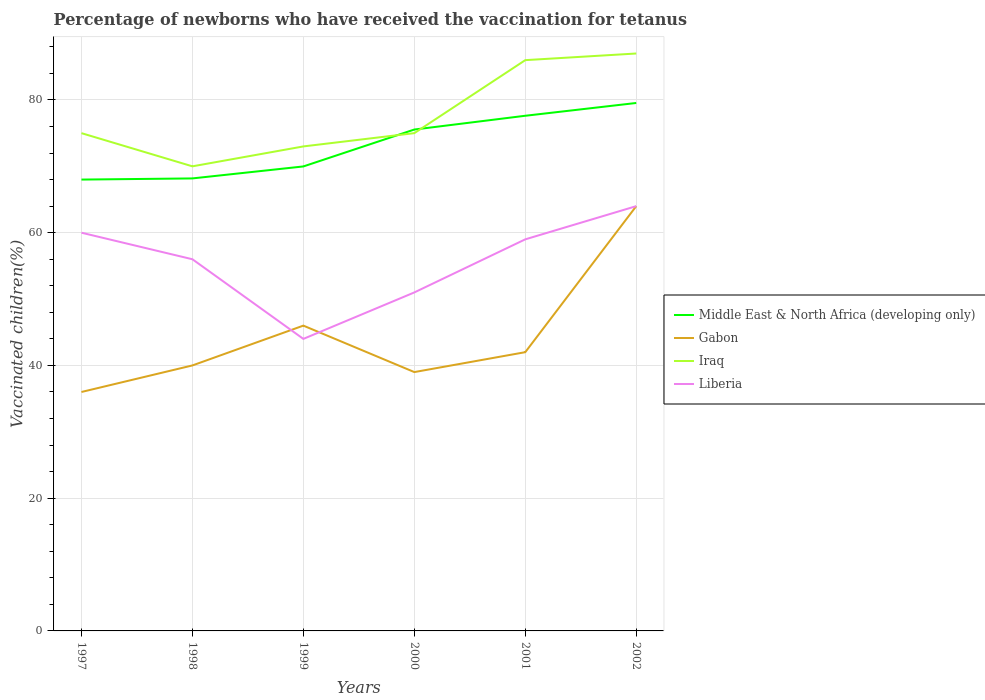Is the number of lines equal to the number of legend labels?
Your answer should be compact. Yes. Across all years, what is the maximum percentage of vaccinated children in Middle East & North Africa (developing only)?
Your response must be concise. 68. What is the total percentage of vaccinated children in Middle East & North Africa (developing only) in the graph?
Provide a succinct answer. -2.07. What is the difference between the highest and the second highest percentage of vaccinated children in Gabon?
Keep it short and to the point. 28. What is the difference between the highest and the lowest percentage of vaccinated children in Liberia?
Give a very brief answer. 4. How many lines are there?
Keep it short and to the point. 4. Does the graph contain grids?
Keep it short and to the point. Yes. Where does the legend appear in the graph?
Provide a short and direct response. Center right. What is the title of the graph?
Your response must be concise. Percentage of newborns who have received the vaccination for tetanus. Does "Brazil" appear as one of the legend labels in the graph?
Offer a very short reply. No. What is the label or title of the Y-axis?
Make the answer very short. Vaccinated children(%). What is the Vaccinated children(%) in Middle East & North Africa (developing only) in 1997?
Your answer should be compact. 68. What is the Vaccinated children(%) of Gabon in 1997?
Offer a very short reply. 36. What is the Vaccinated children(%) of Iraq in 1997?
Your answer should be very brief. 75. What is the Vaccinated children(%) of Middle East & North Africa (developing only) in 1998?
Offer a terse response. 68.18. What is the Vaccinated children(%) in Iraq in 1998?
Your response must be concise. 70. What is the Vaccinated children(%) of Liberia in 1998?
Give a very brief answer. 56. What is the Vaccinated children(%) in Middle East & North Africa (developing only) in 1999?
Ensure brevity in your answer.  69.98. What is the Vaccinated children(%) in Iraq in 1999?
Make the answer very short. 73. What is the Vaccinated children(%) of Middle East & North Africa (developing only) in 2000?
Ensure brevity in your answer.  75.54. What is the Vaccinated children(%) in Gabon in 2000?
Ensure brevity in your answer.  39. What is the Vaccinated children(%) in Iraq in 2000?
Your answer should be very brief. 75. What is the Vaccinated children(%) in Liberia in 2000?
Make the answer very short. 51. What is the Vaccinated children(%) of Middle East & North Africa (developing only) in 2001?
Provide a short and direct response. 77.62. What is the Vaccinated children(%) of Liberia in 2001?
Your response must be concise. 59. What is the Vaccinated children(%) in Middle East & North Africa (developing only) in 2002?
Give a very brief answer. 79.55. What is the Vaccinated children(%) in Gabon in 2002?
Provide a succinct answer. 64. Across all years, what is the maximum Vaccinated children(%) in Middle East & North Africa (developing only)?
Offer a very short reply. 79.55. Across all years, what is the maximum Vaccinated children(%) in Gabon?
Give a very brief answer. 64. Across all years, what is the maximum Vaccinated children(%) of Iraq?
Your response must be concise. 87. Across all years, what is the maximum Vaccinated children(%) of Liberia?
Your answer should be very brief. 64. Across all years, what is the minimum Vaccinated children(%) in Middle East & North Africa (developing only)?
Offer a terse response. 68. Across all years, what is the minimum Vaccinated children(%) in Iraq?
Keep it short and to the point. 70. Across all years, what is the minimum Vaccinated children(%) in Liberia?
Ensure brevity in your answer.  44. What is the total Vaccinated children(%) of Middle East & North Africa (developing only) in the graph?
Ensure brevity in your answer.  438.88. What is the total Vaccinated children(%) in Gabon in the graph?
Provide a succinct answer. 267. What is the total Vaccinated children(%) of Iraq in the graph?
Make the answer very short. 466. What is the total Vaccinated children(%) in Liberia in the graph?
Offer a terse response. 334. What is the difference between the Vaccinated children(%) in Middle East & North Africa (developing only) in 1997 and that in 1998?
Make the answer very short. -0.17. What is the difference between the Vaccinated children(%) in Liberia in 1997 and that in 1998?
Offer a terse response. 4. What is the difference between the Vaccinated children(%) in Middle East & North Africa (developing only) in 1997 and that in 1999?
Your answer should be compact. -1.98. What is the difference between the Vaccinated children(%) in Gabon in 1997 and that in 1999?
Your answer should be very brief. -10. What is the difference between the Vaccinated children(%) in Iraq in 1997 and that in 1999?
Your answer should be very brief. 2. What is the difference between the Vaccinated children(%) of Middle East & North Africa (developing only) in 1997 and that in 2000?
Ensure brevity in your answer.  -7.54. What is the difference between the Vaccinated children(%) in Gabon in 1997 and that in 2000?
Your response must be concise. -3. What is the difference between the Vaccinated children(%) in Liberia in 1997 and that in 2000?
Give a very brief answer. 9. What is the difference between the Vaccinated children(%) of Middle East & North Africa (developing only) in 1997 and that in 2001?
Your answer should be very brief. -9.61. What is the difference between the Vaccinated children(%) of Gabon in 1997 and that in 2001?
Your answer should be very brief. -6. What is the difference between the Vaccinated children(%) of Iraq in 1997 and that in 2001?
Your answer should be compact. -11. What is the difference between the Vaccinated children(%) of Middle East & North Africa (developing only) in 1997 and that in 2002?
Offer a terse response. -11.54. What is the difference between the Vaccinated children(%) of Middle East & North Africa (developing only) in 1998 and that in 1999?
Offer a very short reply. -1.8. What is the difference between the Vaccinated children(%) of Gabon in 1998 and that in 1999?
Your answer should be very brief. -6. What is the difference between the Vaccinated children(%) of Liberia in 1998 and that in 1999?
Provide a succinct answer. 12. What is the difference between the Vaccinated children(%) of Middle East & North Africa (developing only) in 1998 and that in 2000?
Your answer should be compact. -7.37. What is the difference between the Vaccinated children(%) of Gabon in 1998 and that in 2000?
Make the answer very short. 1. What is the difference between the Vaccinated children(%) in Liberia in 1998 and that in 2000?
Keep it short and to the point. 5. What is the difference between the Vaccinated children(%) of Middle East & North Africa (developing only) in 1998 and that in 2001?
Ensure brevity in your answer.  -9.44. What is the difference between the Vaccinated children(%) of Middle East & North Africa (developing only) in 1998 and that in 2002?
Provide a short and direct response. -11.37. What is the difference between the Vaccinated children(%) of Gabon in 1998 and that in 2002?
Ensure brevity in your answer.  -24. What is the difference between the Vaccinated children(%) in Liberia in 1998 and that in 2002?
Offer a terse response. -8. What is the difference between the Vaccinated children(%) of Middle East & North Africa (developing only) in 1999 and that in 2000?
Keep it short and to the point. -5.56. What is the difference between the Vaccinated children(%) of Gabon in 1999 and that in 2000?
Provide a short and direct response. 7. What is the difference between the Vaccinated children(%) in Middle East & North Africa (developing only) in 1999 and that in 2001?
Keep it short and to the point. -7.63. What is the difference between the Vaccinated children(%) in Liberia in 1999 and that in 2001?
Give a very brief answer. -15. What is the difference between the Vaccinated children(%) in Middle East & North Africa (developing only) in 1999 and that in 2002?
Offer a very short reply. -9.56. What is the difference between the Vaccinated children(%) in Gabon in 1999 and that in 2002?
Your answer should be very brief. -18. What is the difference between the Vaccinated children(%) of Liberia in 1999 and that in 2002?
Your answer should be compact. -20. What is the difference between the Vaccinated children(%) in Middle East & North Africa (developing only) in 2000 and that in 2001?
Make the answer very short. -2.07. What is the difference between the Vaccinated children(%) in Gabon in 2000 and that in 2001?
Your answer should be compact. -3. What is the difference between the Vaccinated children(%) in Iraq in 2000 and that in 2001?
Your response must be concise. -11. What is the difference between the Vaccinated children(%) of Middle East & North Africa (developing only) in 2000 and that in 2002?
Your response must be concise. -4. What is the difference between the Vaccinated children(%) of Liberia in 2000 and that in 2002?
Your answer should be compact. -13. What is the difference between the Vaccinated children(%) in Middle East & North Africa (developing only) in 2001 and that in 2002?
Make the answer very short. -1.93. What is the difference between the Vaccinated children(%) of Middle East & North Africa (developing only) in 1997 and the Vaccinated children(%) of Gabon in 1998?
Make the answer very short. 28. What is the difference between the Vaccinated children(%) of Middle East & North Africa (developing only) in 1997 and the Vaccinated children(%) of Iraq in 1998?
Provide a succinct answer. -2. What is the difference between the Vaccinated children(%) in Middle East & North Africa (developing only) in 1997 and the Vaccinated children(%) in Liberia in 1998?
Your response must be concise. 12. What is the difference between the Vaccinated children(%) in Gabon in 1997 and the Vaccinated children(%) in Iraq in 1998?
Offer a very short reply. -34. What is the difference between the Vaccinated children(%) in Gabon in 1997 and the Vaccinated children(%) in Liberia in 1998?
Make the answer very short. -20. What is the difference between the Vaccinated children(%) of Iraq in 1997 and the Vaccinated children(%) of Liberia in 1998?
Make the answer very short. 19. What is the difference between the Vaccinated children(%) in Middle East & North Africa (developing only) in 1997 and the Vaccinated children(%) in Gabon in 1999?
Your response must be concise. 22. What is the difference between the Vaccinated children(%) of Middle East & North Africa (developing only) in 1997 and the Vaccinated children(%) of Iraq in 1999?
Ensure brevity in your answer.  -5. What is the difference between the Vaccinated children(%) of Middle East & North Africa (developing only) in 1997 and the Vaccinated children(%) of Liberia in 1999?
Ensure brevity in your answer.  24. What is the difference between the Vaccinated children(%) of Gabon in 1997 and the Vaccinated children(%) of Iraq in 1999?
Your answer should be very brief. -37. What is the difference between the Vaccinated children(%) in Gabon in 1997 and the Vaccinated children(%) in Liberia in 1999?
Offer a terse response. -8. What is the difference between the Vaccinated children(%) in Middle East & North Africa (developing only) in 1997 and the Vaccinated children(%) in Gabon in 2000?
Give a very brief answer. 29. What is the difference between the Vaccinated children(%) of Middle East & North Africa (developing only) in 1997 and the Vaccinated children(%) of Iraq in 2000?
Offer a terse response. -7. What is the difference between the Vaccinated children(%) in Middle East & North Africa (developing only) in 1997 and the Vaccinated children(%) in Liberia in 2000?
Give a very brief answer. 17. What is the difference between the Vaccinated children(%) of Gabon in 1997 and the Vaccinated children(%) of Iraq in 2000?
Offer a terse response. -39. What is the difference between the Vaccinated children(%) in Gabon in 1997 and the Vaccinated children(%) in Liberia in 2000?
Provide a succinct answer. -15. What is the difference between the Vaccinated children(%) of Iraq in 1997 and the Vaccinated children(%) of Liberia in 2000?
Ensure brevity in your answer.  24. What is the difference between the Vaccinated children(%) in Middle East & North Africa (developing only) in 1997 and the Vaccinated children(%) in Gabon in 2001?
Your answer should be compact. 26. What is the difference between the Vaccinated children(%) of Middle East & North Africa (developing only) in 1997 and the Vaccinated children(%) of Iraq in 2001?
Your response must be concise. -18. What is the difference between the Vaccinated children(%) of Middle East & North Africa (developing only) in 1997 and the Vaccinated children(%) of Liberia in 2001?
Your response must be concise. 9. What is the difference between the Vaccinated children(%) in Gabon in 1997 and the Vaccinated children(%) in Liberia in 2001?
Provide a short and direct response. -23. What is the difference between the Vaccinated children(%) of Middle East & North Africa (developing only) in 1997 and the Vaccinated children(%) of Gabon in 2002?
Provide a succinct answer. 4. What is the difference between the Vaccinated children(%) of Middle East & North Africa (developing only) in 1997 and the Vaccinated children(%) of Iraq in 2002?
Keep it short and to the point. -19. What is the difference between the Vaccinated children(%) in Middle East & North Africa (developing only) in 1997 and the Vaccinated children(%) in Liberia in 2002?
Offer a terse response. 4. What is the difference between the Vaccinated children(%) in Gabon in 1997 and the Vaccinated children(%) in Iraq in 2002?
Provide a short and direct response. -51. What is the difference between the Vaccinated children(%) of Gabon in 1997 and the Vaccinated children(%) of Liberia in 2002?
Provide a short and direct response. -28. What is the difference between the Vaccinated children(%) in Middle East & North Africa (developing only) in 1998 and the Vaccinated children(%) in Gabon in 1999?
Provide a succinct answer. 22.18. What is the difference between the Vaccinated children(%) of Middle East & North Africa (developing only) in 1998 and the Vaccinated children(%) of Iraq in 1999?
Your response must be concise. -4.82. What is the difference between the Vaccinated children(%) of Middle East & North Africa (developing only) in 1998 and the Vaccinated children(%) of Liberia in 1999?
Keep it short and to the point. 24.18. What is the difference between the Vaccinated children(%) of Gabon in 1998 and the Vaccinated children(%) of Iraq in 1999?
Provide a succinct answer. -33. What is the difference between the Vaccinated children(%) of Gabon in 1998 and the Vaccinated children(%) of Liberia in 1999?
Keep it short and to the point. -4. What is the difference between the Vaccinated children(%) in Iraq in 1998 and the Vaccinated children(%) in Liberia in 1999?
Your answer should be very brief. 26. What is the difference between the Vaccinated children(%) of Middle East & North Africa (developing only) in 1998 and the Vaccinated children(%) of Gabon in 2000?
Provide a short and direct response. 29.18. What is the difference between the Vaccinated children(%) in Middle East & North Africa (developing only) in 1998 and the Vaccinated children(%) in Iraq in 2000?
Your answer should be very brief. -6.82. What is the difference between the Vaccinated children(%) of Middle East & North Africa (developing only) in 1998 and the Vaccinated children(%) of Liberia in 2000?
Your answer should be compact. 17.18. What is the difference between the Vaccinated children(%) of Gabon in 1998 and the Vaccinated children(%) of Iraq in 2000?
Give a very brief answer. -35. What is the difference between the Vaccinated children(%) of Gabon in 1998 and the Vaccinated children(%) of Liberia in 2000?
Give a very brief answer. -11. What is the difference between the Vaccinated children(%) of Iraq in 1998 and the Vaccinated children(%) of Liberia in 2000?
Provide a short and direct response. 19. What is the difference between the Vaccinated children(%) in Middle East & North Africa (developing only) in 1998 and the Vaccinated children(%) in Gabon in 2001?
Your response must be concise. 26.18. What is the difference between the Vaccinated children(%) of Middle East & North Africa (developing only) in 1998 and the Vaccinated children(%) of Iraq in 2001?
Make the answer very short. -17.82. What is the difference between the Vaccinated children(%) in Middle East & North Africa (developing only) in 1998 and the Vaccinated children(%) in Liberia in 2001?
Provide a succinct answer. 9.18. What is the difference between the Vaccinated children(%) in Gabon in 1998 and the Vaccinated children(%) in Iraq in 2001?
Make the answer very short. -46. What is the difference between the Vaccinated children(%) in Middle East & North Africa (developing only) in 1998 and the Vaccinated children(%) in Gabon in 2002?
Keep it short and to the point. 4.18. What is the difference between the Vaccinated children(%) of Middle East & North Africa (developing only) in 1998 and the Vaccinated children(%) of Iraq in 2002?
Make the answer very short. -18.82. What is the difference between the Vaccinated children(%) in Middle East & North Africa (developing only) in 1998 and the Vaccinated children(%) in Liberia in 2002?
Keep it short and to the point. 4.18. What is the difference between the Vaccinated children(%) of Gabon in 1998 and the Vaccinated children(%) of Iraq in 2002?
Make the answer very short. -47. What is the difference between the Vaccinated children(%) in Middle East & North Africa (developing only) in 1999 and the Vaccinated children(%) in Gabon in 2000?
Ensure brevity in your answer.  30.98. What is the difference between the Vaccinated children(%) in Middle East & North Africa (developing only) in 1999 and the Vaccinated children(%) in Iraq in 2000?
Keep it short and to the point. -5.02. What is the difference between the Vaccinated children(%) in Middle East & North Africa (developing only) in 1999 and the Vaccinated children(%) in Liberia in 2000?
Give a very brief answer. 18.98. What is the difference between the Vaccinated children(%) in Gabon in 1999 and the Vaccinated children(%) in Iraq in 2000?
Your answer should be very brief. -29. What is the difference between the Vaccinated children(%) in Iraq in 1999 and the Vaccinated children(%) in Liberia in 2000?
Ensure brevity in your answer.  22. What is the difference between the Vaccinated children(%) in Middle East & North Africa (developing only) in 1999 and the Vaccinated children(%) in Gabon in 2001?
Give a very brief answer. 27.98. What is the difference between the Vaccinated children(%) of Middle East & North Africa (developing only) in 1999 and the Vaccinated children(%) of Iraq in 2001?
Provide a succinct answer. -16.02. What is the difference between the Vaccinated children(%) in Middle East & North Africa (developing only) in 1999 and the Vaccinated children(%) in Liberia in 2001?
Keep it short and to the point. 10.98. What is the difference between the Vaccinated children(%) of Gabon in 1999 and the Vaccinated children(%) of Liberia in 2001?
Offer a terse response. -13. What is the difference between the Vaccinated children(%) of Iraq in 1999 and the Vaccinated children(%) of Liberia in 2001?
Make the answer very short. 14. What is the difference between the Vaccinated children(%) in Middle East & North Africa (developing only) in 1999 and the Vaccinated children(%) in Gabon in 2002?
Provide a short and direct response. 5.98. What is the difference between the Vaccinated children(%) in Middle East & North Africa (developing only) in 1999 and the Vaccinated children(%) in Iraq in 2002?
Offer a terse response. -17.02. What is the difference between the Vaccinated children(%) of Middle East & North Africa (developing only) in 1999 and the Vaccinated children(%) of Liberia in 2002?
Your answer should be compact. 5.98. What is the difference between the Vaccinated children(%) in Gabon in 1999 and the Vaccinated children(%) in Iraq in 2002?
Offer a terse response. -41. What is the difference between the Vaccinated children(%) of Gabon in 1999 and the Vaccinated children(%) of Liberia in 2002?
Offer a very short reply. -18. What is the difference between the Vaccinated children(%) in Middle East & North Africa (developing only) in 2000 and the Vaccinated children(%) in Gabon in 2001?
Your answer should be very brief. 33.54. What is the difference between the Vaccinated children(%) of Middle East & North Africa (developing only) in 2000 and the Vaccinated children(%) of Iraq in 2001?
Provide a succinct answer. -10.46. What is the difference between the Vaccinated children(%) in Middle East & North Africa (developing only) in 2000 and the Vaccinated children(%) in Liberia in 2001?
Your answer should be compact. 16.54. What is the difference between the Vaccinated children(%) of Gabon in 2000 and the Vaccinated children(%) of Iraq in 2001?
Make the answer very short. -47. What is the difference between the Vaccinated children(%) of Gabon in 2000 and the Vaccinated children(%) of Liberia in 2001?
Ensure brevity in your answer.  -20. What is the difference between the Vaccinated children(%) in Iraq in 2000 and the Vaccinated children(%) in Liberia in 2001?
Offer a terse response. 16. What is the difference between the Vaccinated children(%) in Middle East & North Africa (developing only) in 2000 and the Vaccinated children(%) in Gabon in 2002?
Your response must be concise. 11.54. What is the difference between the Vaccinated children(%) of Middle East & North Africa (developing only) in 2000 and the Vaccinated children(%) of Iraq in 2002?
Make the answer very short. -11.46. What is the difference between the Vaccinated children(%) of Middle East & North Africa (developing only) in 2000 and the Vaccinated children(%) of Liberia in 2002?
Your answer should be very brief. 11.54. What is the difference between the Vaccinated children(%) in Gabon in 2000 and the Vaccinated children(%) in Iraq in 2002?
Your answer should be very brief. -48. What is the difference between the Vaccinated children(%) in Gabon in 2000 and the Vaccinated children(%) in Liberia in 2002?
Provide a succinct answer. -25. What is the difference between the Vaccinated children(%) of Middle East & North Africa (developing only) in 2001 and the Vaccinated children(%) of Gabon in 2002?
Offer a very short reply. 13.62. What is the difference between the Vaccinated children(%) in Middle East & North Africa (developing only) in 2001 and the Vaccinated children(%) in Iraq in 2002?
Offer a terse response. -9.38. What is the difference between the Vaccinated children(%) in Middle East & North Africa (developing only) in 2001 and the Vaccinated children(%) in Liberia in 2002?
Offer a terse response. 13.62. What is the difference between the Vaccinated children(%) of Gabon in 2001 and the Vaccinated children(%) of Iraq in 2002?
Your answer should be very brief. -45. What is the difference between the Vaccinated children(%) of Iraq in 2001 and the Vaccinated children(%) of Liberia in 2002?
Provide a short and direct response. 22. What is the average Vaccinated children(%) of Middle East & North Africa (developing only) per year?
Ensure brevity in your answer.  73.15. What is the average Vaccinated children(%) of Gabon per year?
Provide a short and direct response. 44.5. What is the average Vaccinated children(%) in Iraq per year?
Your answer should be very brief. 77.67. What is the average Vaccinated children(%) of Liberia per year?
Your response must be concise. 55.67. In the year 1997, what is the difference between the Vaccinated children(%) of Middle East & North Africa (developing only) and Vaccinated children(%) of Gabon?
Your answer should be very brief. 32. In the year 1997, what is the difference between the Vaccinated children(%) of Middle East & North Africa (developing only) and Vaccinated children(%) of Iraq?
Your answer should be compact. -7. In the year 1997, what is the difference between the Vaccinated children(%) in Middle East & North Africa (developing only) and Vaccinated children(%) in Liberia?
Offer a very short reply. 8. In the year 1997, what is the difference between the Vaccinated children(%) in Gabon and Vaccinated children(%) in Iraq?
Ensure brevity in your answer.  -39. In the year 1997, what is the difference between the Vaccinated children(%) of Iraq and Vaccinated children(%) of Liberia?
Keep it short and to the point. 15. In the year 1998, what is the difference between the Vaccinated children(%) of Middle East & North Africa (developing only) and Vaccinated children(%) of Gabon?
Give a very brief answer. 28.18. In the year 1998, what is the difference between the Vaccinated children(%) in Middle East & North Africa (developing only) and Vaccinated children(%) in Iraq?
Ensure brevity in your answer.  -1.82. In the year 1998, what is the difference between the Vaccinated children(%) of Middle East & North Africa (developing only) and Vaccinated children(%) of Liberia?
Your answer should be very brief. 12.18. In the year 1998, what is the difference between the Vaccinated children(%) of Gabon and Vaccinated children(%) of Liberia?
Ensure brevity in your answer.  -16. In the year 1998, what is the difference between the Vaccinated children(%) of Iraq and Vaccinated children(%) of Liberia?
Offer a very short reply. 14. In the year 1999, what is the difference between the Vaccinated children(%) in Middle East & North Africa (developing only) and Vaccinated children(%) in Gabon?
Your answer should be very brief. 23.98. In the year 1999, what is the difference between the Vaccinated children(%) of Middle East & North Africa (developing only) and Vaccinated children(%) of Iraq?
Your answer should be compact. -3.02. In the year 1999, what is the difference between the Vaccinated children(%) in Middle East & North Africa (developing only) and Vaccinated children(%) in Liberia?
Give a very brief answer. 25.98. In the year 1999, what is the difference between the Vaccinated children(%) in Iraq and Vaccinated children(%) in Liberia?
Give a very brief answer. 29. In the year 2000, what is the difference between the Vaccinated children(%) in Middle East & North Africa (developing only) and Vaccinated children(%) in Gabon?
Provide a short and direct response. 36.54. In the year 2000, what is the difference between the Vaccinated children(%) in Middle East & North Africa (developing only) and Vaccinated children(%) in Iraq?
Give a very brief answer. 0.54. In the year 2000, what is the difference between the Vaccinated children(%) of Middle East & North Africa (developing only) and Vaccinated children(%) of Liberia?
Keep it short and to the point. 24.54. In the year 2000, what is the difference between the Vaccinated children(%) in Gabon and Vaccinated children(%) in Iraq?
Ensure brevity in your answer.  -36. In the year 2000, what is the difference between the Vaccinated children(%) of Gabon and Vaccinated children(%) of Liberia?
Offer a very short reply. -12. In the year 2000, what is the difference between the Vaccinated children(%) of Iraq and Vaccinated children(%) of Liberia?
Your answer should be compact. 24. In the year 2001, what is the difference between the Vaccinated children(%) of Middle East & North Africa (developing only) and Vaccinated children(%) of Gabon?
Your answer should be very brief. 35.62. In the year 2001, what is the difference between the Vaccinated children(%) in Middle East & North Africa (developing only) and Vaccinated children(%) in Iraq?
Your answer should be very brief. -8.38. In the year 2001, what is the difference between the Vaccinated children(%) in Middle East & North Africa (developing only) and Vaccinated children(%) in Liberia?
Offer a very short reply. 18.62. In the year 2001, what is the difference between the Vaccinated children(%) in Gabon and Vaccinated children(%) in Iraq?
Provide a short and direct response. -44. In the year 2001, what is the difference between the Vaccinated children(%) of Gabon and Vaccinated children(%) of Liberia?
Make the answer very short. -17. In the year 2001, what is the difference between the Vaccinated children(%) in Iraq and Vaccinated children(%) in Liberia?
Provide a short and direct response. 27. In the year 2002, what is the difference between the Vaccinated children(%) of Middle East & North Africa (developing only) and Vaccinated children(%) of Gabon?
Your answer should be very brief. 15.55. In the year 2002, what is the difference between the Vaccinated children(%) in Middle East & North Africa (developing only) and Vaccinated children(%) in Iraq?
Your answer should be very brief. -7.45. In the year 2002, what is the difference between the Vaccinated children(%) of Middle East & North Africa (developing only) and Vaccinated children(%) of Liberia?
Your response must be concise. 15.55. In the year 2002, what is the difference between the Vaccinated children(%) of Gabon and Vaccinated children(%) of Liberia?
Offer a very short reply. 0. In the year 2002, what is the difference between the Vaccinated children(%) in Iraq and Vaccinated children(%) in Liberia?
Offer a terse response. 23. What is the ratio of the Vaccinated children(%) in Middle East & North Africa (developing only) in 1997 to that in 1998?
Keep it short and to the point. 1. What is the ratio of the Vaccinated children(%) in Gabon in 1997 to that in 1998?
Provide a short and direct response. 0.9. What is the ratio of the Vaccinated children(%) of Iraq in 1997 to that in 1998?
Your answer should be compact. 1.07. What is the ratio of the Vaccinated children(%) of Liberia in 1997 to that in 1998?
Offer a very short reply. 1.07. What is the ratio of the Vaccinated children(%) of Middle East & North Africa (developing only) in 1997 to that in 1999?
Offer a terse response. 0.97. What is the ratio of the Vaccinated children(%) of Gabon in 1997 to that in 1999?
Offer a very short reply. 0.78. What is the ratio of the Vaccinated children(%) of Iraq in 1997 to that in 1999?
Give a very brief answer. 1.03. What is the ratio of the Vaccinated children(%) in Liberia in 1997 to that in 1999?
Your answer should be very brief. 1.36. What is the ratio of the Vaccinated children(%) in Middle East & North Africa (developing only) in 1997 to that in 2000?
Your answer should be very brief. 0.9. What is the ratio of the Vaccinated children(%) of Liberia in 1997 to that in 2000?
Provide a short and direct response. 1.18. What is the ratio of the Vaccinated children(%) in Middle East & North Africa (developing only) in 1997 to that in 2001?
Your answer should be very brief. 0.88. What is the ratio of the Vaccinated children(%) in Gabon in 1997 to that in 2001?
Provide a short and direct response. 0.86. What is the ratio of the Vaccinated children(%) of Iraq in 1997 to that in 2001?
Ensure brevity in your answer.  0.87. What is the ratio of the Vaccinated children(%) of Liberia in 1997 to that in 2001?
Your response must be concise. 1.02. What is the ratio of the Vaccinated children(%) in Middle East & North Africa (developing only) in 1997 to that in 2002?
Offer a very short reply. 0.85. What is the ratio of the Vaccinated children(%) in Gabon in 1997 to that in 2002?
Keep it short and to the point. 0.56. What is the ratio of the Vaccinated children(%) in Iraq in 1997 to that in 2002?
Ensure brevity in your answer.  0.86. What is the ratio of the Vaccinated children(%) of Liberia in 1997 to that in 2002?
Offer a very short reply. 0.94. What is the ratio of the Vaccinated children(%) in Middle East & North Africa (developing only) in 1998 to that in 1999?
Make the answer very short. 0.97. What is the ratio of the Vaccinated children(%) of Gabon in 1998 to that in 1999?
Provide a succinct answer. 0.87. What is the ratio of the Vaccinated children(%) in Iraq in 1998 to that in 1999?
Make the answer very short. 0.96. What is the ratio of the Vaccinated children(%) of Liberia in 1998 to that in 1999?
Provide a short and direct response. 1.27. What is the ratio of the Vaccinated children(%) of Middle East & North Africa (developing only) in 1998 to that in 2000?
Provide a short and direct response. 0.9. What is the ratio of the Vaccinated children(%) of Gabon in 1998 to that in 2000?
Offer a terse response. 1.03. What is the ratio of the Vaccinated children(%) in Liberia in 1998 to that in 2000?
Keep it short and to the point. 1.1. What is the ratio of the Vaccinated children(%) in Middle East & North Africa (developing only) in 1998 to that in 2001?
Give a very brief answer. 0.88. What is the ratio of the Vaccinated children(%) in Gabon in 1998 to that in 2001?
Ensure brevity in your answer.  0.95. What is the ratio of the Vaccinated children(%) in Iraq in 1998 to that in 2001?
Offer a terse response. 0.81. What is the ratio of the Vaccinated children(%) of Liberia in 1998 to that in 2001?
Make the answer very short. 0.95. What is the ratio of the Vaccinated children(%) of Gabon in 1998 to that in 2002?
Provide a succinct answer. 0.62. What is the ratio of the Vaccinated children(%) in Iraq in 1998 to that in 2002?
Offer a terse response. 0.8. What is the ratio of the Vaccinated children(%) in Liberia in 1998 to that in 2002?
Make the answer very short. 0.88. What is the ratio of the Vaccinated children(%) of Middle East & North Africa (developing only) in 1999 to that in 2000?
Ensure brevity in your answer.  0.93. What is the ratio of the Vaccinated children(%) of Gabon in 1999 to that in 2000?
Provide a succinct answer. 1.18. What is the ratio of the Vaccinated children(%) of Iraq in 1999 to that in 2000?
Provide a short and direct response. 0.97. What is the ratio of the Vaccinated children(%) of Liberia in 1999 to that in 2000?
Your response must be concise. 0.86. What is the ratio of the Vaccinated children(%) in Middle East & North Africa (developing only) in 1999 to that in 2001?
Provide a short and direct response. 0.9. What is the ratio of the Vaccinated children(%) of Gabon in 1999 to that in 2001?
Keep it short and to the point. 1.1. What is the ratio of the Vaccinated children(%) in Iraq in 1999 to that in 2001?
Provide a succinct answer. 0.85. What is the ratio of the Vaccinated children(%) in Liberia in 1999 to that in 2001?
Your response must be concise. 0.75. What is the ratio of the Vaccinated children(%) in Middle East & North Africa (developing only) in 1999 to that in 2002?
Ensure brevity in your answer.  0.88. What is the ratio of the Vaccinated children(%) in Gabon in 1999 to that in 2002?
Make the answer very short. 0.72. What is the ratio of the Vaccinated children(%) in Iraq in 1999 to that in 2002?
Your response must be concise. 0.84. What is the ratio of the Vaccinated children(%) in Liberia in 1999 to that in 2002?
Your answer should be very brief. 0.69. What is the ratio of the Vaccinated children(%) in Middle East & North Africa (developing only) in 2000 to that in 2001?
Keep it short and to the point. 0.97. What is the ratio of the Vaccinated children(%) of Gabon in 2000 to that in 2001?
Provide a succinct answer. 0.93. What is the ratio of the Vaccinated children(%) of Iraq in 2000 to that in 2001?
Keep it short and to the point. 0.87. What is the ratio of the Vaccinated children(%) of Liberia in 2000 to that in 2001?
Your response must be concise. 0.86. What is the ratio of the Vaccinated children(%) in Middle East & North Africa (developing only) in 2000 to that in 2002?
Provide a short and direct response. 0.95. What is the ratio of the Vaccinated children(%) of Gabon in 2000 to that in 2002?
Your answer should be compact. 0.61. What is the ratio of the Vaccinated children(%) of Iraq in 2000 to that in 2002?
Keep it short and to the point. 0.86. What is the ratio of the Vaccinated children(%) of Liberia in 2000 to that in 2002?
Your answer should be very brief. 0.8. What is the ratio of the Vaccinated children(%) in Middle East & North Africa (developing only) in 2001 to that in 2002?
Your answer should be compact. 0.98. What is the ratio of the Vaccinated children(%) in Gabon in 2001 to that in 2002?
Your answer should be very brief. 0.66. What is the ratio of the Vaccinated children(%) in Iraq in 2001 to that in 2002?
Make the answer very short. 0.99. What is the ratio of the Vaccinated children(%) in Liberia in 2001 to that in 2002?
Make the answer very short. 0.92. What is the difference between the highest and the second highest Vaccinated children(%) of Middle East & North Africa (developing only)?
Give a very brief answer. 1.93. What is the difference between the highest and the second highest Vaccinated children(%) of Gabon?
Keep it short and to the point. 18. What is the difference between the highest and the second highest Vaccinated children(%) of Iraq?
Offer a terse response. 1. What is the difference between the highest and the second highest Vaccinated children(%) of Liberia?
Keep it short and to the point. 4. What is the difference between the highest and the lowest Vaccinated children(%) in Middle East & North Africa (developing only)?
Keep it short and to the point. 11.54. What is the difference between the highest and the lowest Vaccinated children(%) in Gabon?
Your answer should be compact. 28. What is the difference between the highest and the lowest Vaccinated children(%) of Liberia?
Provide a succinct answer. 20. 